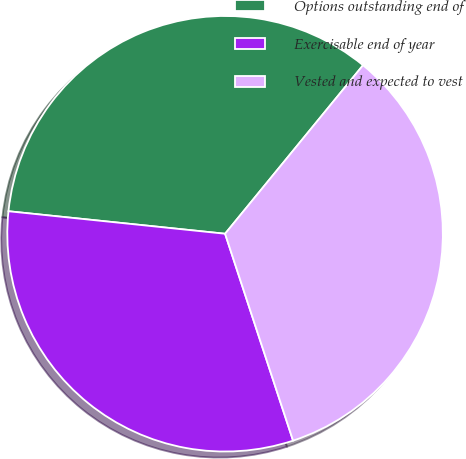Convert chart. <chart><loc_0><loc_0><loc_500><loc_500><pie_chart><fcel>Options outstanding end of<fcel>Exercisable end of year<fcel>Vested and expected to vest<nl><fcel>34.27%<fcel>31.7%<fcel>34.03%<nl></chart> 